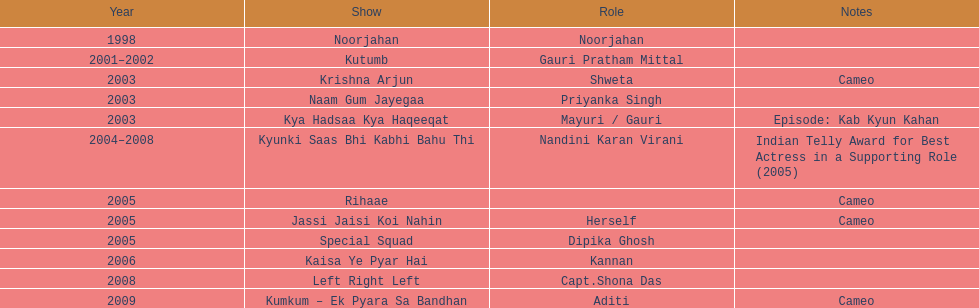In how many various tv programs did gauri tejwani appear before 2000? 1. 